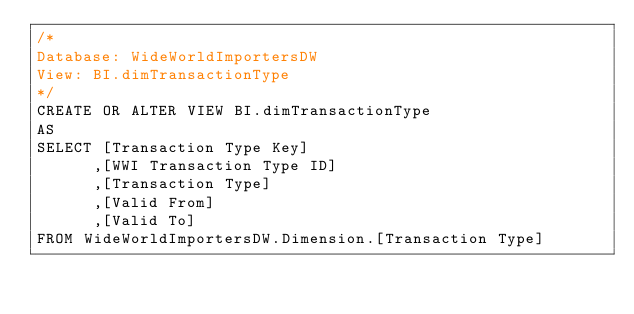Convert code to text. <code><loc_0><loc_0><loc_500><loc_500><_SQL_>/*
Database: WideWorldImportersDW
View: BI.dimTransactionType
*/
CREATE OR ALTER VIEW BI.dimTransactionType
AS
SELECT [Transaction Type Key]
      ,[WWI Transaction Type ID]
      ,[Transaction Type]
      ,[Valid From]
      ,[Valid To]
FROM WideWorldImportersDW.Dimension.[Transaction Type]</code> 